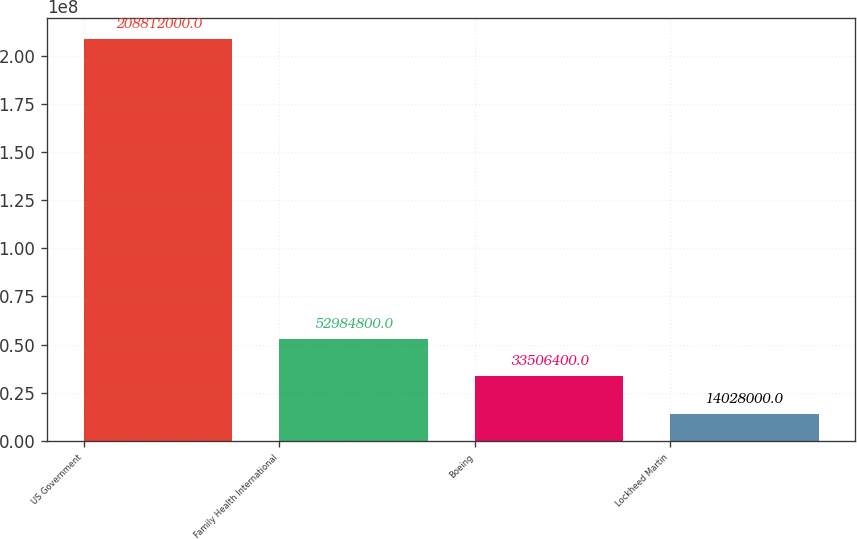Convert chart to OTSL. <chart><loc_0><loc_0><loc_500><loc_500><bar_chart><fcel>US Government<fcel>Family Health International<fcel>Boeing<fcel>Lockheed Martin<nl><fcel>2.08812e+08<fcel>5.29848e+07<fcel>3.35064e+07<fcel>1.4028e+07<nl></chart> 